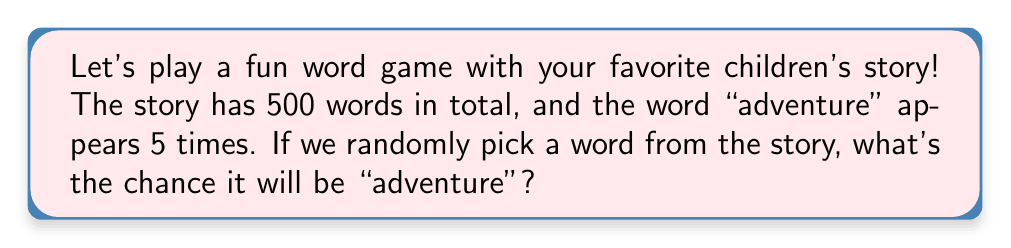Give your solution to this math problem. Let's break this down step-by-step:

1. First, we need to understand what probability means. Probability is the likelihood of an event happening, and it's calculated by dividing the number of favorable outcomes by the total number of possible outcomes.

2. In this case:
   - The favorable outcome is picking the word "adventure"
   - The total number of possible outcomes is picking any word in the story

3. We know that:
   - The word "adventure" appears 5 times
   - The story has 500 words in total

4. Now, let's set up our probability calculation:

   $$ P(\text{picking "adventure"}) = \frac{\text{number of times "adventure" appears}}{\text{total number of words}} $$

5. Plugging in our numbers:

   $$ P(\text{picking "adventure"}) = \frac{5}{500} $$

6. To simplify this fraction, we can divide both the numerator and denominator by 5:

   $$ P(\text{picking "adventure"}) = \frac{1}{100} = 0.01 $$

7. We can also express this as a percentage:

   $$ 0.01 \times 100\% = 1\% $$

So, there's a 1% chance of randomly picking the word "adventure" from the story.
Answer: $\frac{1}{100}$ or 0.01 or 1% 